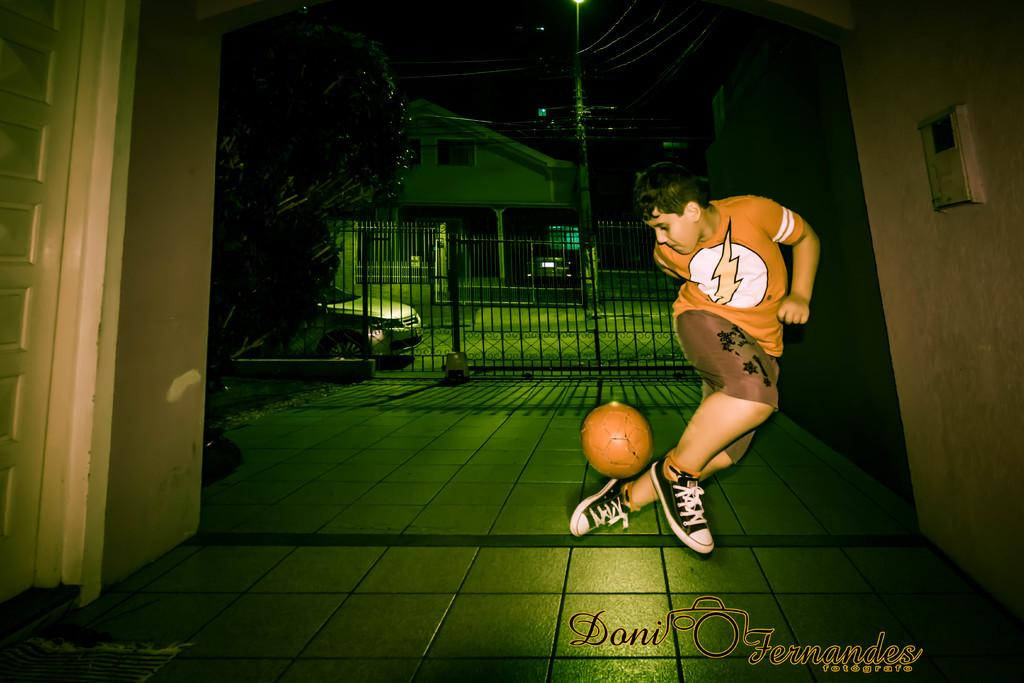Who is the main subject in the image? There is a boy in the image. What is the boy doing in the image? The boy is playing with a football. What can be seen in the background of the image? There is a gate, a car, trees, a building, and a current pole in the background of the image. How many ladybugs are crawling on the football in the image? There are no ladybugs present in the image; the boy is playing with a football. What type of cherry is being used as a decoration on the gate in the image? There is no cherry present in the image, and the gate is not mentioned as having any decorations. 